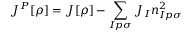Convert formula to latex. <formula><loc_0><loc_0><loc_500><loc_500>J ^ { P } [ \rho ] = J [ \rho ] - \sum _ { I p \sigma } J _ { I } n _ { I p \sigma } ^ { 2 }</formula> 